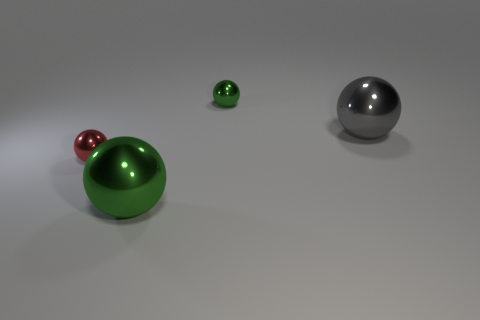There is a big object that is right of the object that is behind the gray ball; what is it made of?
Ensure brevity in your answer.  Metal. There is a small object that is in front of the gray ball; is its shape the same as the big gray object?
Offer a very short reply. Yes. What color is the other big thing that is made of the same material as the big gray object?
Keep it short and to the point. Green. There is a large green shiny thing; does it have the same shape as the metallic thing that is behind the gray sphere?
Provide a succinct answer. Yes. There is a sphere that is both on the right side of the small red ball and to the left of the tiny green metal ball; what is it made of?
Keep it short and to the point. Metal. What color is the other sphere that is the same size as the red sphere?
Offer a very short reply. Green. Does the tiny green ball have the same material as the big object in front of the large gray metal ball?
Provide a short and direct response. Yes. What number of other things are there of the same size as the red metal ball?
Your answer should be compact. 1. Are there any shiny things behind the small metal object that is right of the small shiny thing that is on the left side of the big green metal thing?
Keep it short and to the point. No. The red ball has what size?
Make the answer very short. Small. 